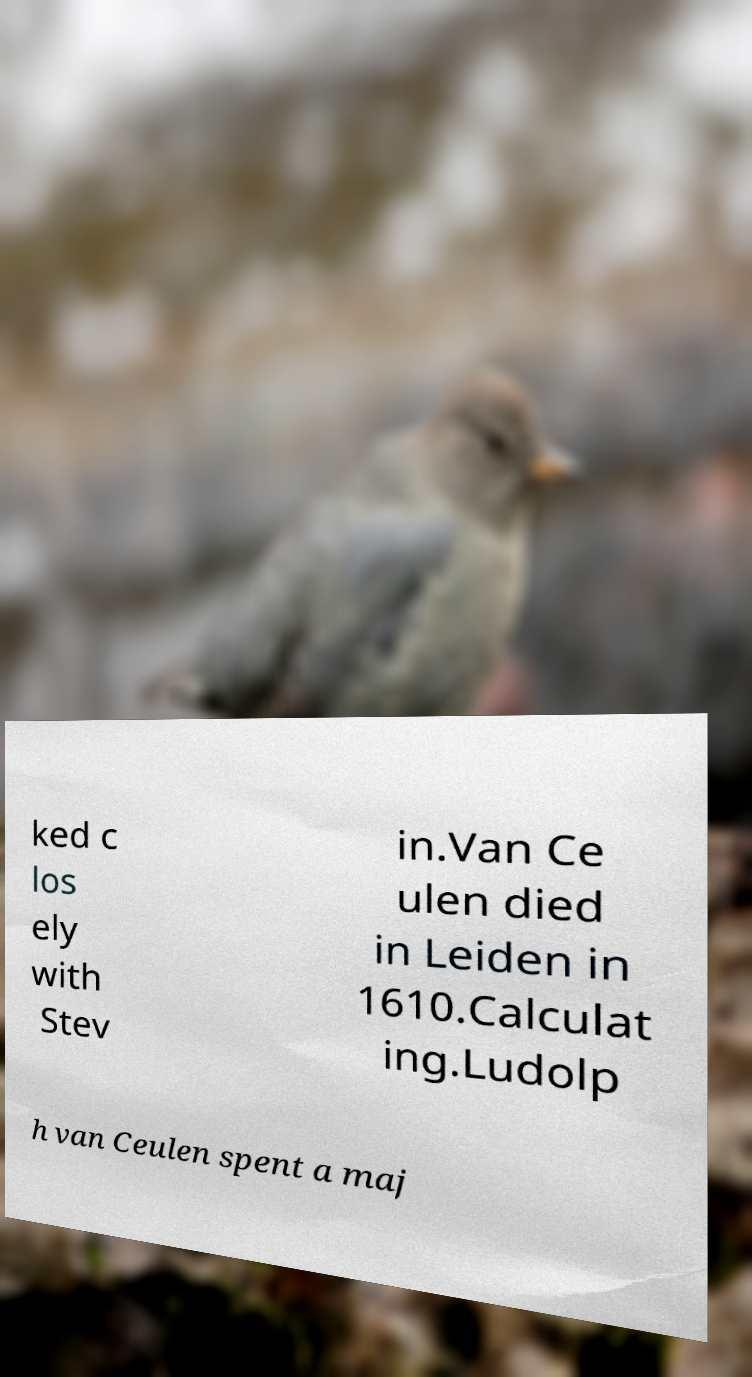What messages or text are displayed in this image? I need them in a readable, typed format. ked c los ely with Stev in.Van Ce ulen died in Leiden in 1610.Calculat ing.Ludolp h van Ceulen spent a maj 